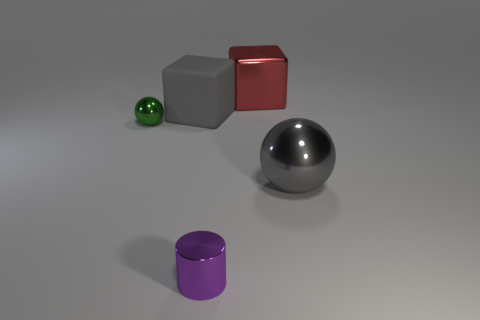Add 2 small yellow matte cubes. How many objects exist? 7 Subtract all balls. How many objects are left? 3 Add 2 green cubes. How many green cubes exist? 2 Subtract 0 green cubes. How many objects are left? 5 Subtract all small purple things. Subtract all large gray metal objects. How many objects are left? 3 Add 1 purple metallic cylinders. How many purple metallic cylinders are left? 2 